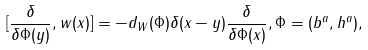Convert formula to latex. <formula><loc_0><loc_0><loc_500><loc_500>[ \frac { \delta } { \delta \Phi ( y ) } , w ( x ) ] = - d _ { W } ( \Phi ) \delta ( x - y ) \frac { \delta } { \delta \Phi ( x ) } , \Phi = ( b ^ { a } , h ^ { a } ) ,</formula> 